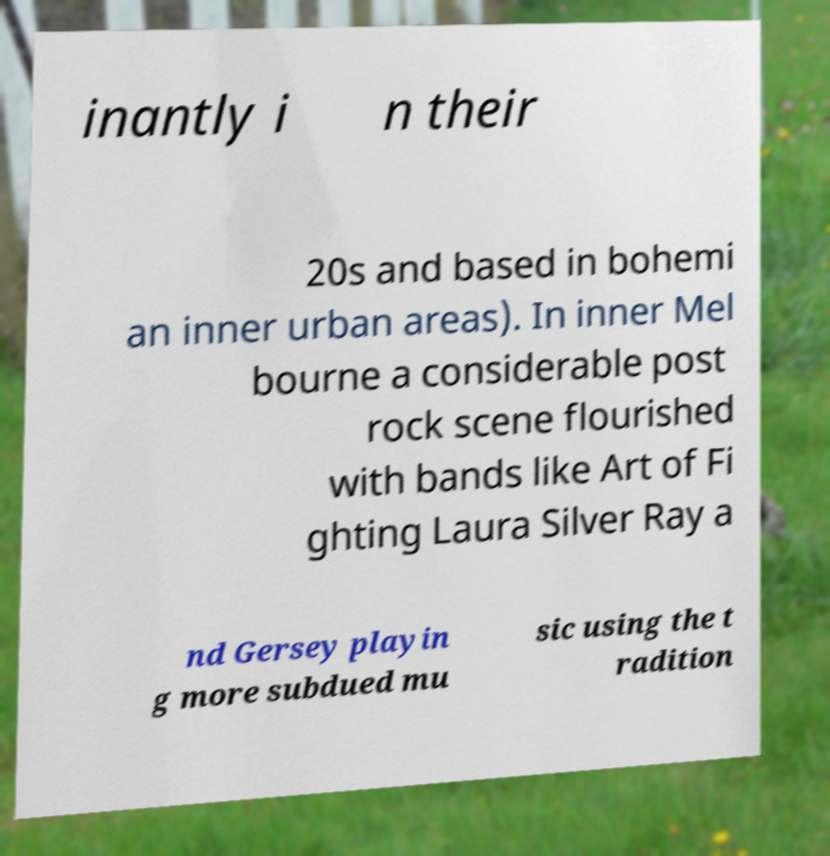I need the written content from this picture converted into text. Can you do that? inantly i n their 20s and based in bohemi an inner urban areas). In inner Mel bourne a considerable post rock scene flourished with bands like Art of Fi ghting Laura Silver Ray a nd Gersey playin g more subdued mu sic using the t radition 